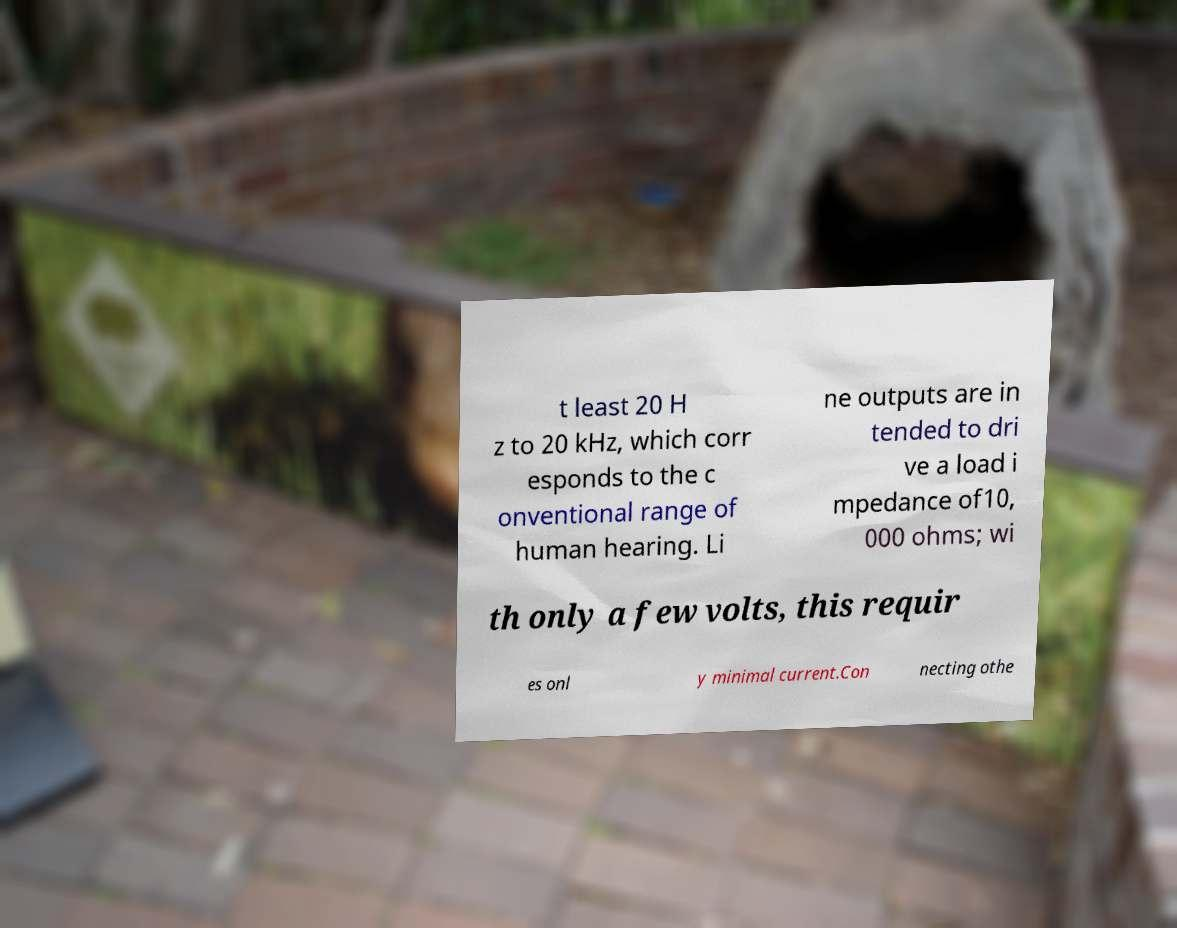Please identify and transcribe the text found in this image. t least 20 H z to 20 kHz, which corr esponds to the c onventional range of human hearing. Li ne outputs are in tended to dri ve a load i mpedance of10, 000 ohms; wi th only a few volts, this requir es onl y minimal current.Con necting othe 